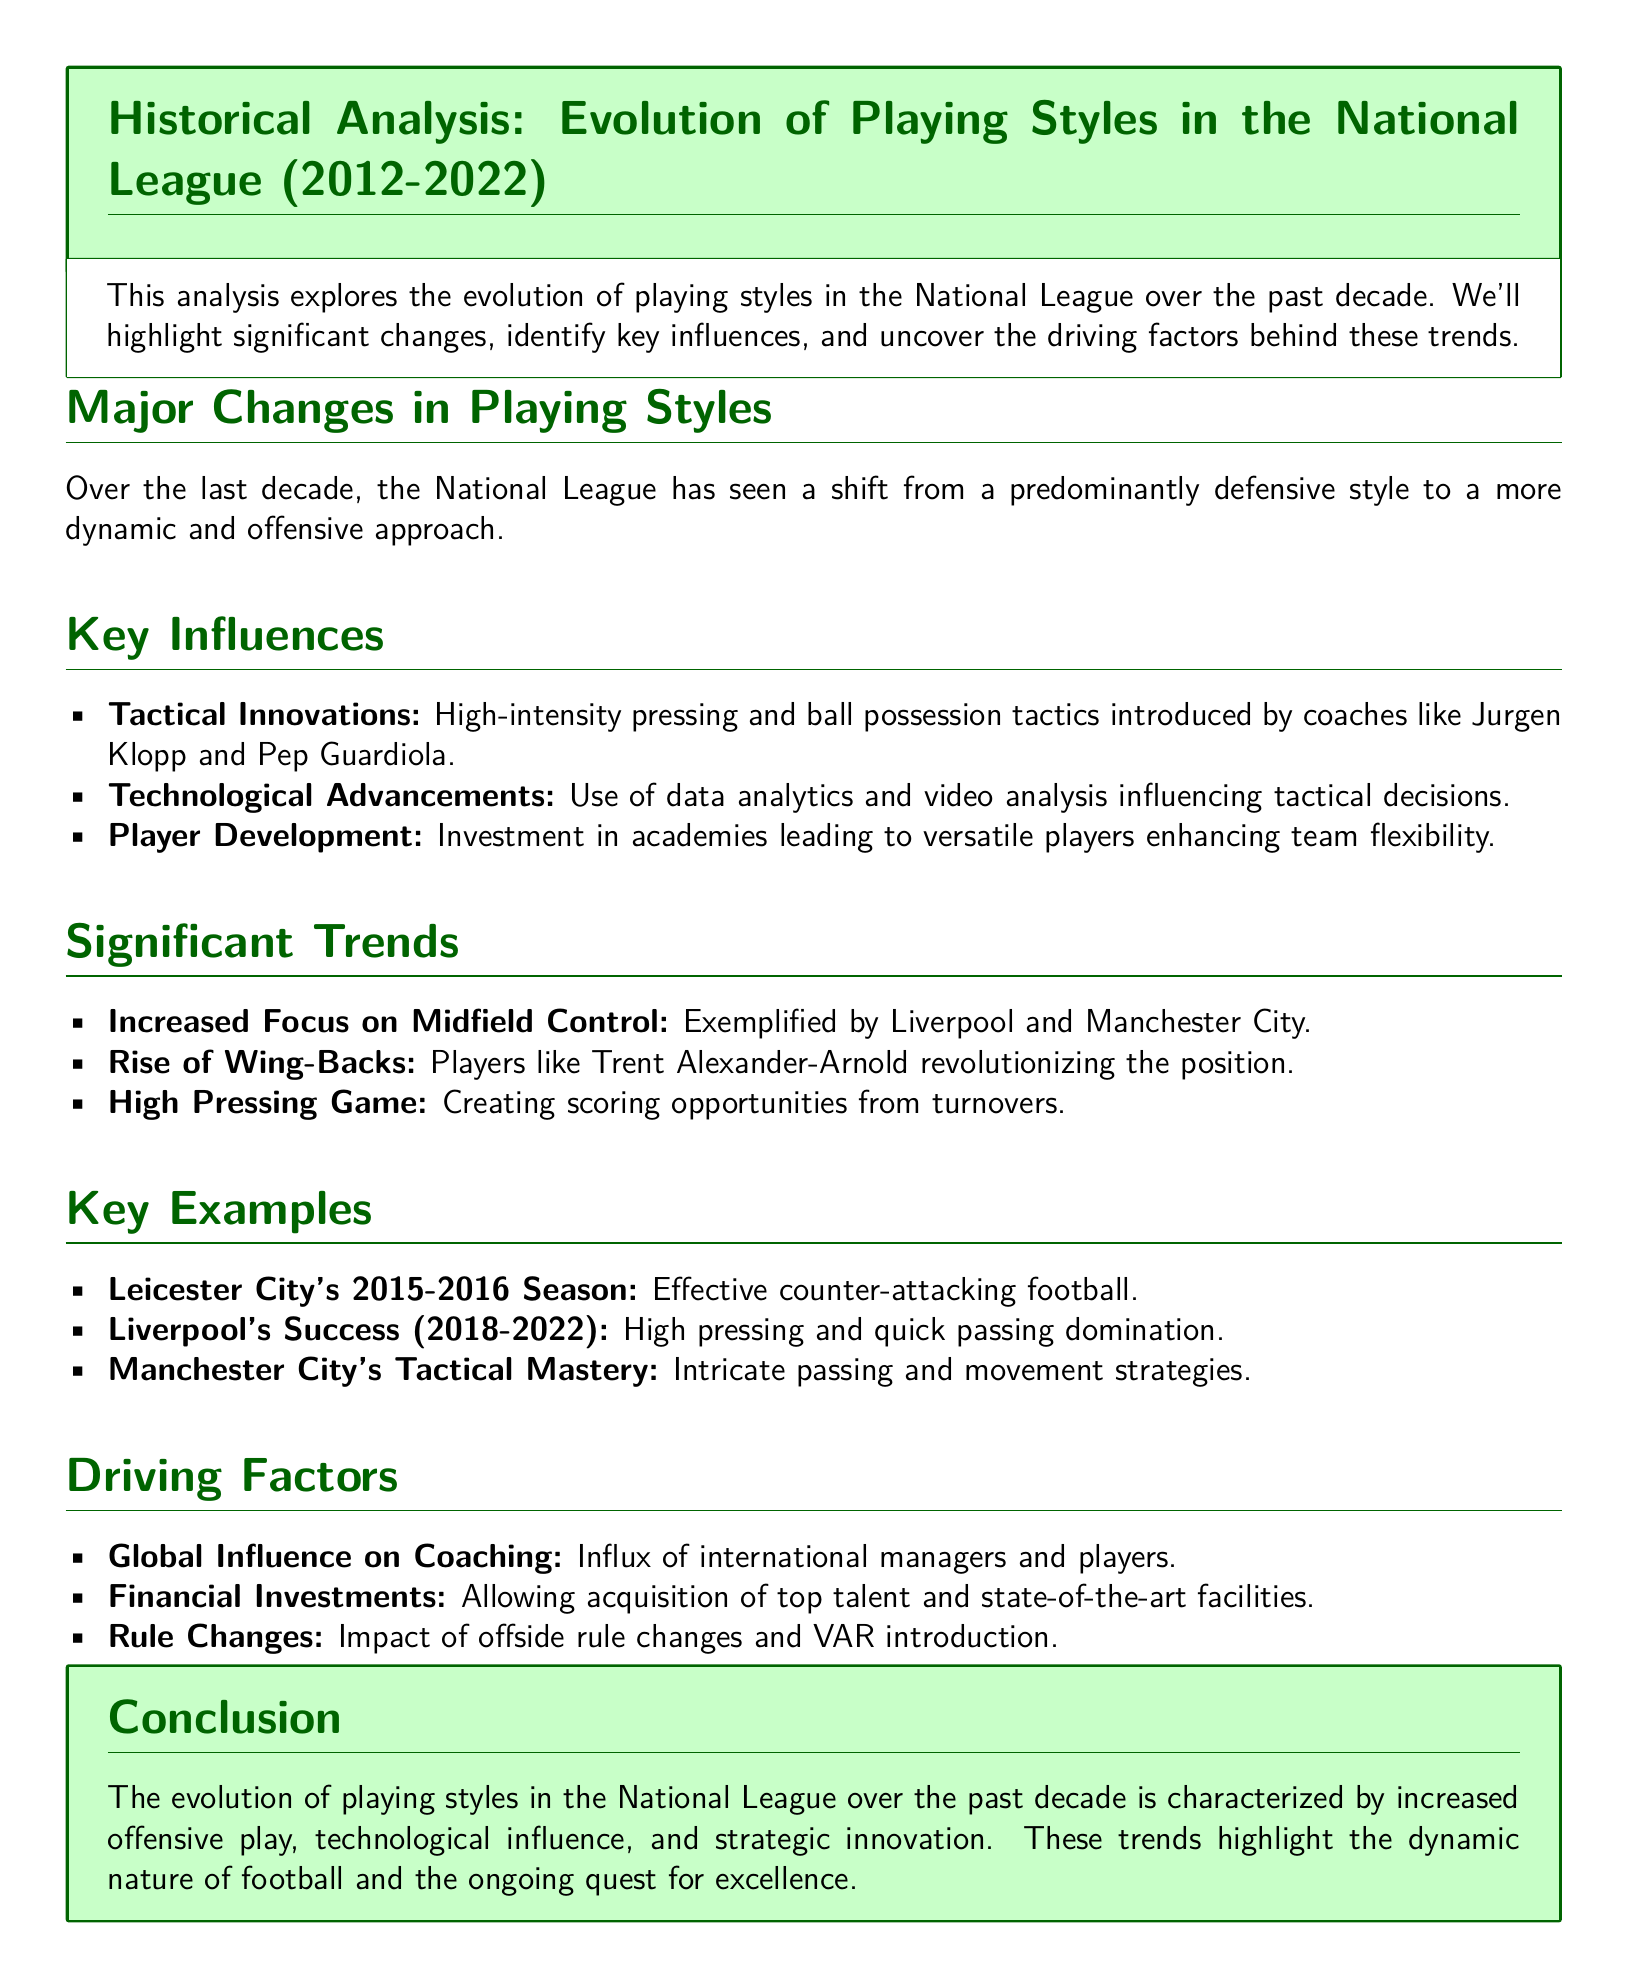What is the time frame of the evolution analyzed in the document? The analysis covers the evolution of playing styles in the National League from 2012 to 2022.
Answer: 2012-2022 What team exemplified a focus on midfield control? The document highlights teams like Liverpool and Manchester City for their increased focus on midfield control.
Answer: Liverpool and Manchester City What style shift has occurred over the last decade? The document states there has been a shift from a predominantly defensive style to a more dynamic and offensive approach.
Answer: Offensive approach Which manager is associated with high-intensity pressing tactics? The analysis mentions coaches like Jurgen Klopp as influential figures in introducing tactical innovations.
Answer: Jurgen Klopp What significant style was revolutionized by Trent Alexander-Arnold? The document indicates that the rise of wing-backs is exemplified by players like Trent Alexander-Arnold.
Answer: Wing-Backs Which team is cited for effective counter-attacking football during the 2015-2016 season? The document gives Leicester City as an example of a team employing effective counter-attacking football.
Answer: Leicester City What factor is mentioned as driving changes in coaching? The document mentions the influx of international managers and players as a global influence on coaching.
Answer: Global influence What offensive strategy is associated with creating scoring opportunities? The high pressing game is identified as a strategy that creates scoring opportunities from turnovers.
Answer: High Pressing Game What aspect of football has been influenced by technological advancements? The document details that data analytics and video analysis have influenced tactical decisions in football.
Answer: Tactical decisions 